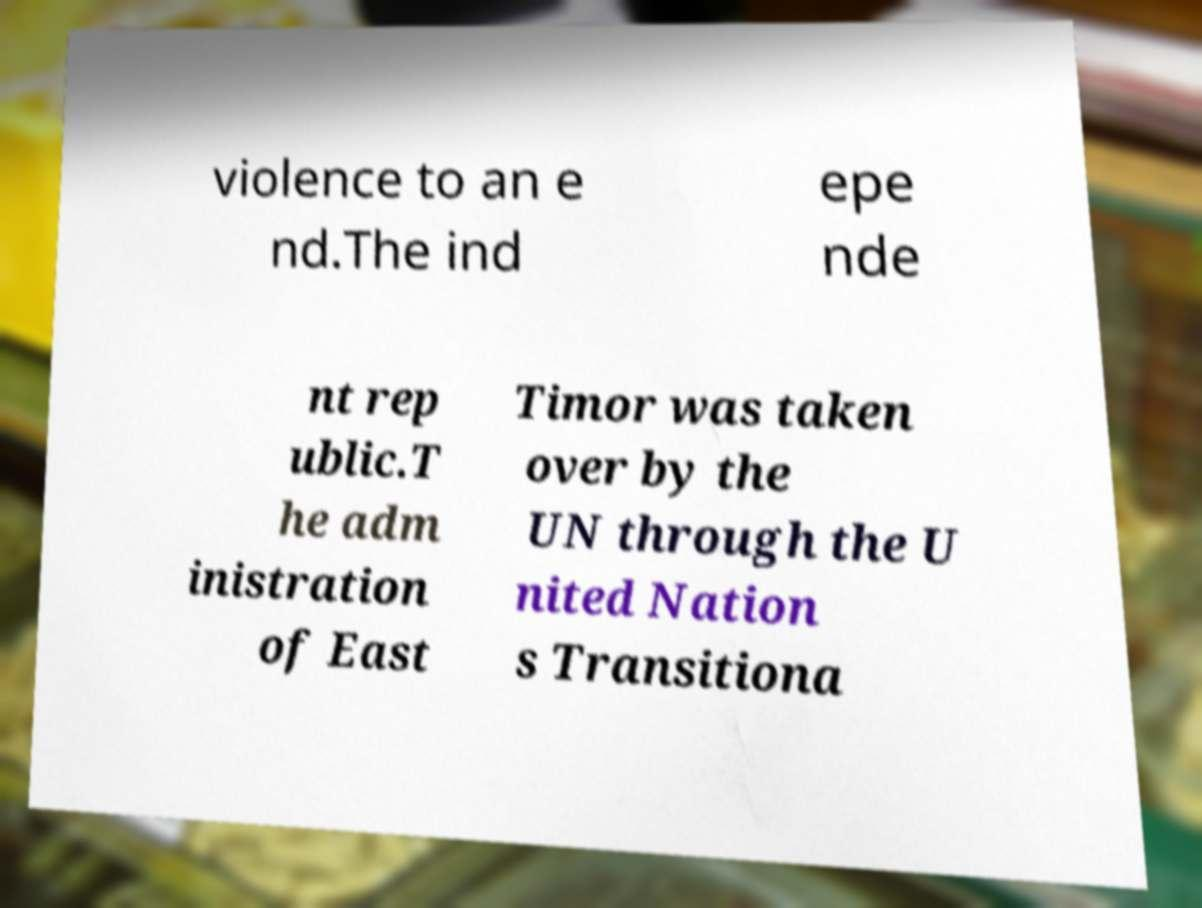Please identify and transcribe the text found in this image. violence to an e nd.The ind epe nde nt rep ublic.T he adm inistration of East Timor was taken over by the UN through the U nited Nation s Transitiona 